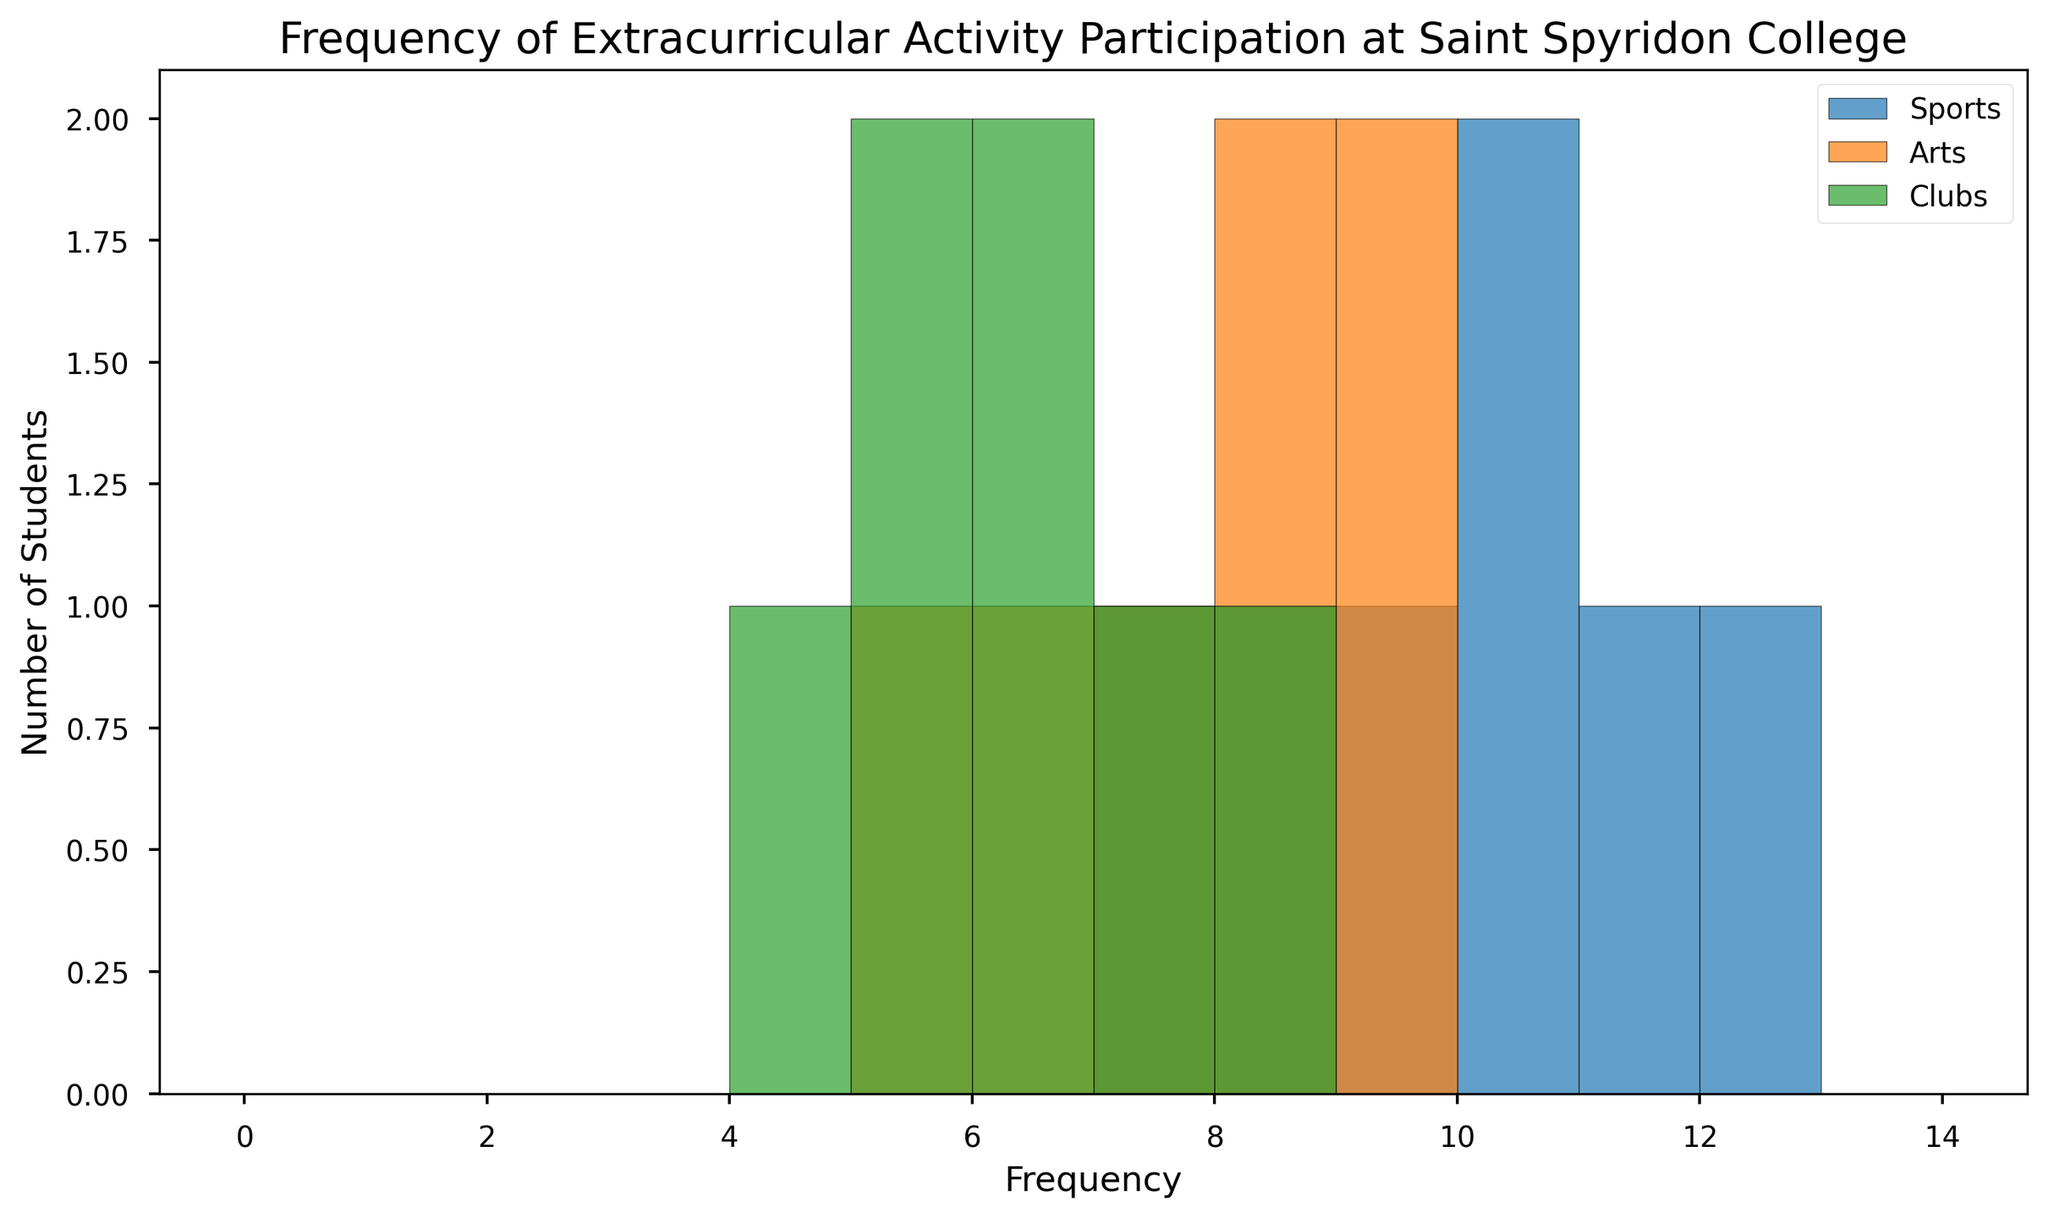What's the most common frequency for Arts participation? By looking at the histogram bars for Arts, the highest bar indicates the most common frequency. This bar is at the frequency of 8.
Answer: 8 Which activity has the highest overall frequency recorded? By comparing the bins on the x-axis, the highest recorded frequency is 12, which is associated with Sports.
Answer: Sports What is the average frequency of Sports participation? List the frequencies for Sports (10, 8, 12, 9, 7, 11, 10), sum them up to get 67, then divide by the number of data points (7), resulting in an average of 67/7.
Answer: 9.57 Which activity shows the least frequent participation among students? By analyzing the smallest bins, Clubs have students participating as infrequently as 4 times, which is lower than Arts and Sports minimum participation frequencies.
Answer: Clubs Which bin has the highest number of participants across all activities? By adding the number of students in each bin across Sports, Arts, and Clubs, the bin for frequency 8 has 2 (Sports) + 2 (Arts) + 1 (Clubs) = 5 students, which is the highest.
Answer: 8 How does the peak participation frequency for Clubs compare with Arts? By identifying the tallest bins for Clubs (frequency of 6) and Arts (frequency of 8), the participation frequency of Arts is higher.
Answer: Arts Which activity has the most consistent level of participation? By evaluating the distribution spread, Arts and Clubs have narrower ranges compared to Sports, indicating more consistent participation. Comparing visual width, Arts has frequencies clustered between 5 and 9, while Clubs range from 4 to 8.
Answer: Arts Calculate the difference in the number of students between the highest and lowest frequency of Sports participation. The highest value for Sports is 12, while the lowest is 7. Therefore, the number of students is 12 - 7 = 5.
Answer: 5 What is the total number of students participating in Arts? By summing the frequencies for Arts (6 + 9 + 8 + 7 + 8 + 5 + 9), we get a total of 52 students.
Answer: 52 Which activity has the majority of participation frequencies in the range of 7 to 9? By comparing the histogram bars within the range of 7 to 9 for each activity, Sports and Arts both have significant participation, but Arts has more occurrences in this range (7, 8, 8, 9) compared to Sports (7, 8, 9).
Answer: Arts 